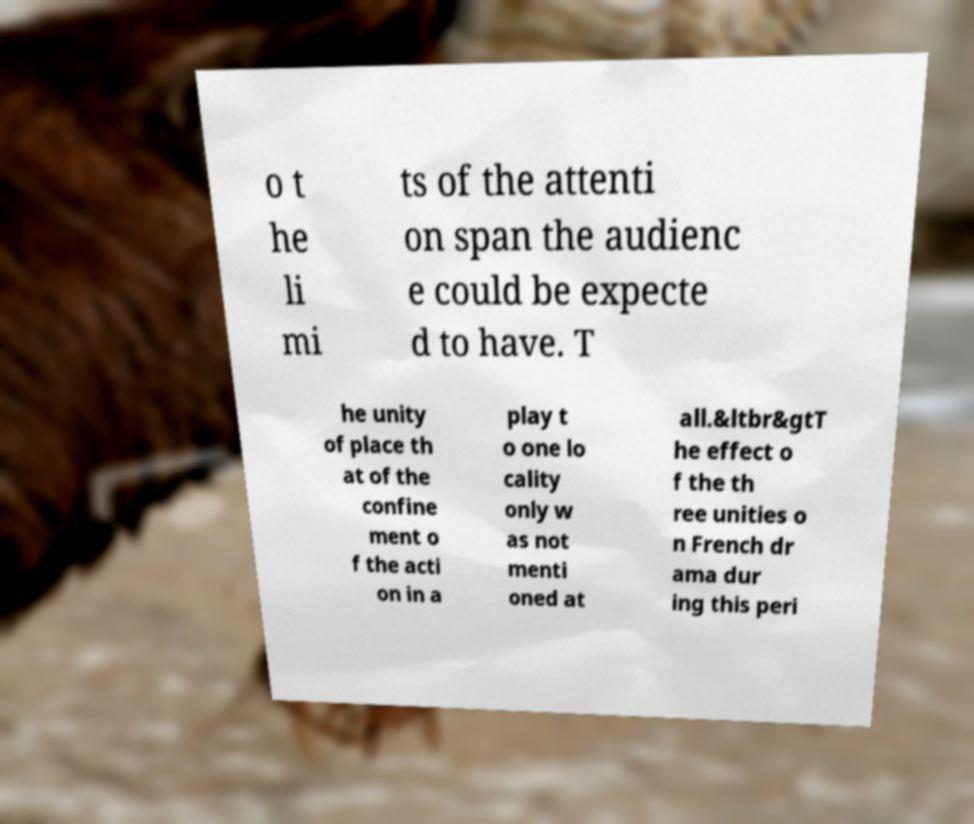Could you assist in decoding the text presented in this image and type it out clearly? o t he li mi ts of the attenti on span the audienc e could be expecte d to have. T he unity of place th at of the confine ment o f the acti on in a play t o one lo cality only w as not menti oned at all.&ltbr&gtT he effect o f the th ree unities o n French dr ama dur ing this peri 